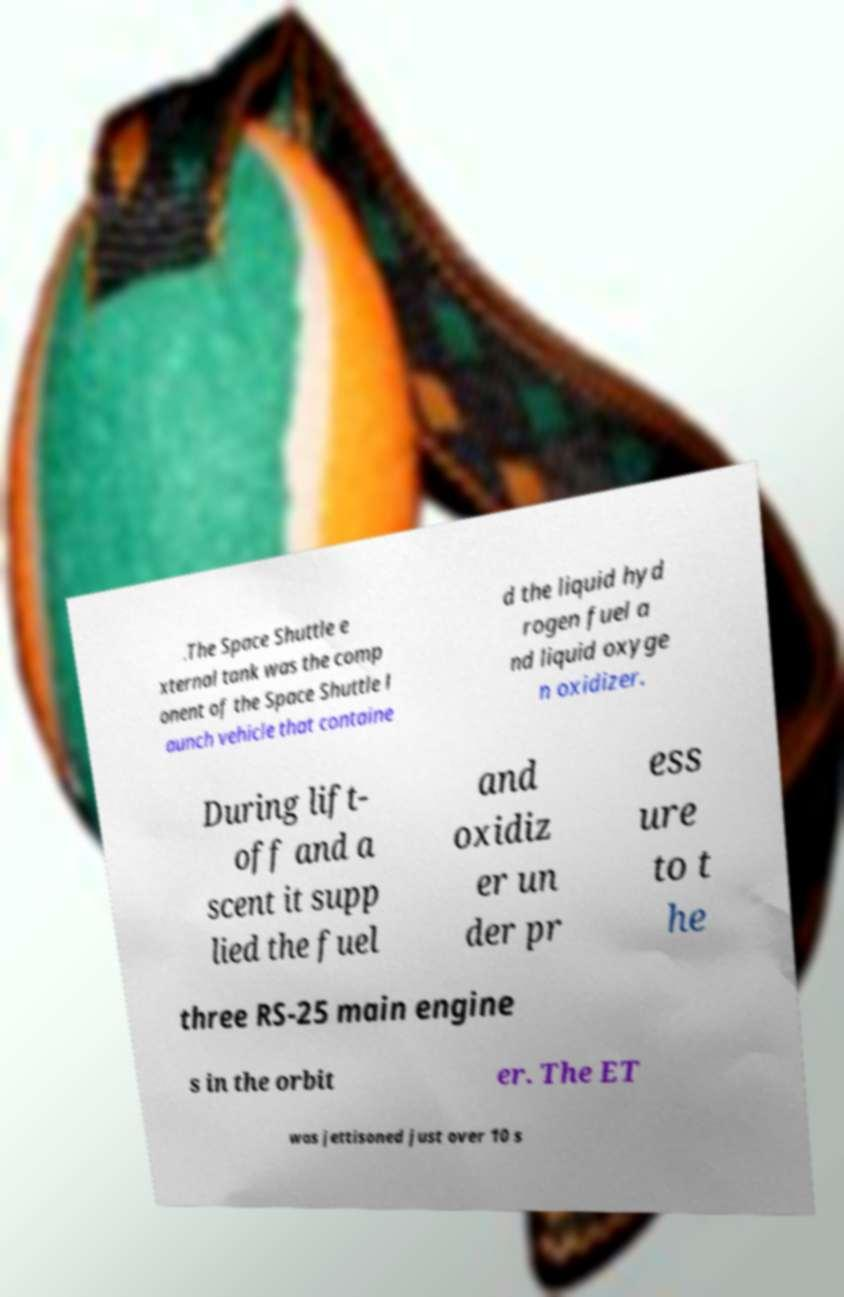What messages or text are displayed in this image? I need them in a readable, typed format. .The Space Shuttle e xternal tank was the comp onent of the Space Shuttle l aunch vehicle that containe d the liquid hyd rogen fuel a nd liquid oxyge n oxidizer. During lift- off and a scent it supp lied the fuel and oxidiz er un der pr ess ure to t he three RS-25 main engine s in the orbit er. The ET was jettisoned just over 10 s 